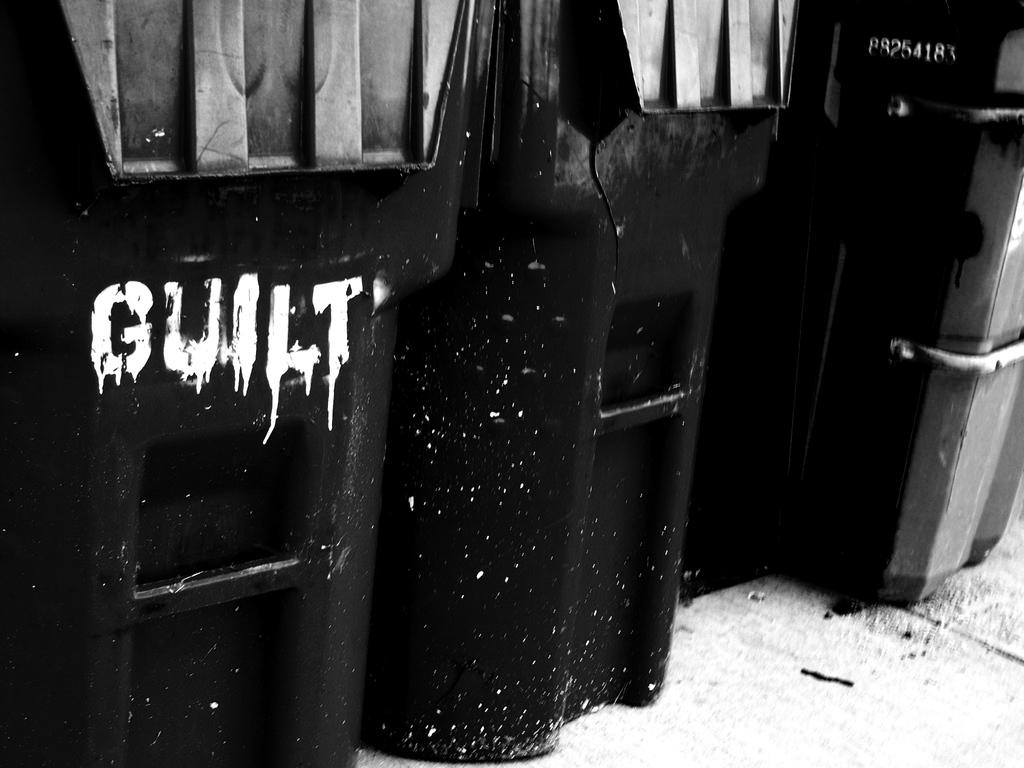Provide a one-sentence caption for the provided image. Black trash cans are lined up, one of which has GUILT scrawled on it. 